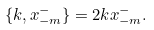Convert formula to latex. <formula><loc_0><loc_0><loc_500><loc_500>\{ k , x _ { - m } ^ { - } \} = 2 k x _ { - m } ^ { - } .</formula> 